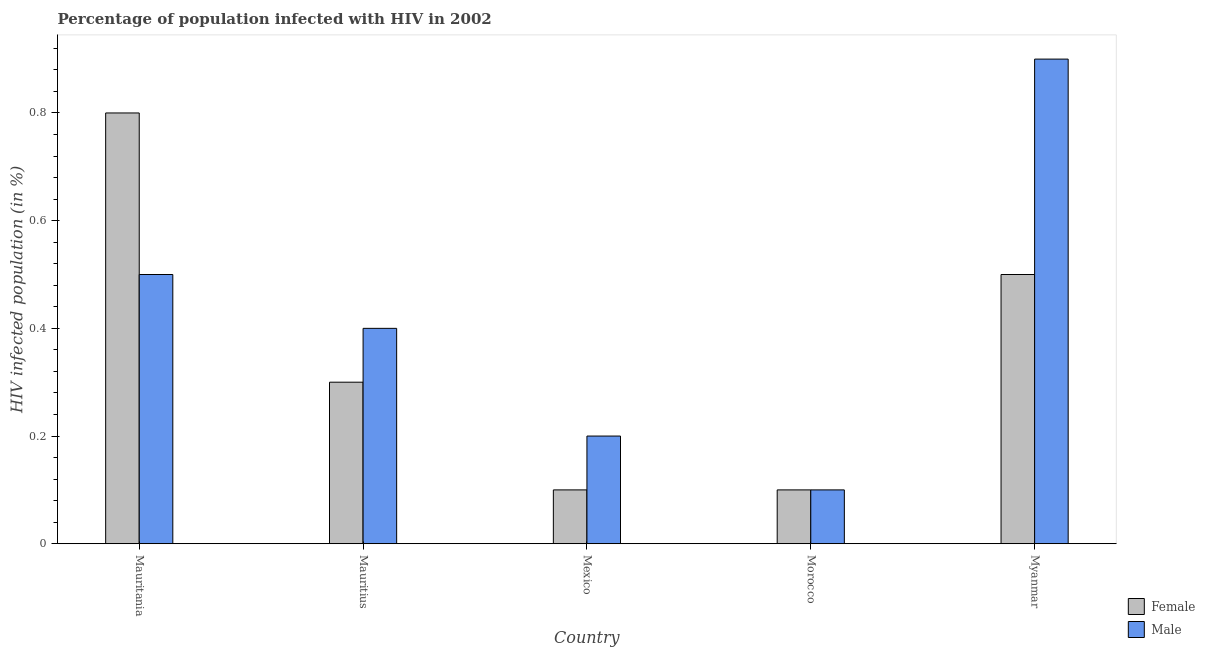How many different coloured bars are there?
Provide a succinct answer. 2. How many groups of bars are there?
Offer a terse response. 5. Are the number of bars on each tick of the X-axis equal?
Keep it short and to the point. Yes. How many bars are there on the 3rd tick from the left?
Ensure brevity in your answer.  2. What is the label of the 5th group of bars from the left?
Offer a terse response. Myanmar. What is the percentage of males who are infected with hiv in Mauritius?
Offer a terse response. 0.4. Across all countries, what is the maximum percentage of males who are infected with hiv?
Keep it short and to the point. 0.9. In which country was the percentage of females who are infected with hiv maximum?
Offer a terse response. Mauritania. In which country was the percentage of females who are infected with hiv minimum?
Your answer should be very brief. Mexico. What is the total percentage of males who are infected with hiv in the graph?
Your answer should be compact. 2.1. What is the average percentage of males who are infected with hiv per country?
Keep it short and to the point. 0.42. What is the difference between the percentage of females who are infected with hiv and percentage of males who are infected with hiv in Mauritania?
Make the answer very short. 0.3. In how many countries, is the percentage of males who are infected with hiv greater than 0.6400000000000001 %?
Provide a succinct answer. 1. What is the ratio of the percentage of males who are infected with hiv in Mauritania to that in Myanmar?
Keep it short and to the point. 0.56. What is the difference between the highest and the second highest percentage of males who are infected with hiv?
Provide a succinct answer. 0.4. What is the difference between the highest and the lowest percentage of females who are infected with hiv?
Ensure brevity in your answer.  0.7. Is the sum of the percentage of males who are infected with hiv in Mauritania and Mexico greater than the maximum percentage of females who are infected with hiv across all countries?
Offer a terse response. No. What does the 1st bar from the right in Mauritius represents?
Your answer should be very brief. Male. How many bars are there?
Keep it short and to the point. 10. Are all the bars in the graph horizontal?
Keep it short and to the point. No. What is the difference between two consecutive major ticks on the Y-axis?
Provide a short and direct response. 0.2. Does the graph contain grids?
Your answer should be compact. No. How are the legend labels stacked?
Make the answer very short. Vertical. What is the title of the graph?
Your response must be concise. Percentage of population infected with HIV in 2002. Does "Private consumption" appear as one of the legend labels in the graph?
Your answer should be very brief. No. What is the label or title of the X-axis?
Offer a very short reply. Country. What is the label or title of the Y-axis?
Your answer should be very brief. HIV infected population (in %). What is the HIV infected population (in %) of Female in Mauritania?
Make the answer very short. 0.8. What is the HIV infected population (in %) of Male in Mauritania?
Make the answer very short. 0.5. What is the HIV infected population (in %) of Female in Mauritius?
Offer a terse response. 0.3. What is the HIV infected population (in %) of Male in Mexico?
Provide a succinct answer. 0.2. What is the HIV infected population (in %) in Female in Morocco?
Provide a succinct answer. 0.1. What is the HIV infected population (in %) in Male in Myanmar?
Provide a short and direct response. 0.9. Across all countries, what is the maximum HIV infected population (in %) in Female?
Provide a short and direct response. 0.8. Across all countries, what is the maximum HIV infected population (in %) of Male?
Ensure brevity in your answer.  0.9. Across all countries, what is the minimum HIV infected population (in %) of Female?
Ensure brevity in your answer.  0.1. What is the total HIV infected population (in %) of Female in the graph?
Offer a very short reply. 1.8. What is the difference between the HIV infected population (in %) of Female in Mauritania and that in Mauritius?
Your answer should be very brief. 0.5. What is the difference between the HIV infected population (in %) of Male in Mauritania and that in Mauritius?
Give a very brief answer. 0.1. What is the difference between the HIV infected population (in %) of Male in Mauritania and that in Mexico?
Provide a short and direct response. 0.3. What is the difference between the HIV infected population (in %) in Female in Mauritania and that in Myanmar?
Provide a succinct answer. 0.3. What is the difference between the HIV infected population (in %) of Male in Mauritania and that in Myanmar?
Your response must be concise. -0.4. What is the difference between the HIV infected population (in %) of Female in Mauritius and that in Mexico?
Keep it short and to the point. 0.2. What is the difference between the HIV infected population (in %) in Male in Mauritius and that in Mexico?
Ensure brevity in your answer.  0.2. What is the difference between the HIV infected population (in %) of Female in Mauritius and that in Morocco?
Make the answer very short. 0.2. What is the difference between the HIV infected population (in %) of Male in Mauritius and that in Myanmar?
Offer a terse response. -0.5. What is the difference between the HIV infected population (in %) in Female in Mexico and that in Morocco?
Provide a short and direct response. 0. What is the difference between the HIV infected population (in %) in Male in Mexico and that in Morocco?
Your answer should be compact. 0.1. What is the difference between the HIV infected population (in %) in Female in Mexico and that in Myanmar?
Your answer should be compact. -0.4. What is the difference between the HIV infected population (in %) in Male in Mexico and that in Myanmar?
Your answer should be compact. -0.7. What is the difference between the HIV infected population (in %) of Male in Morocco and that in Myanmar?
Provide a short and direct response. -0.8. What is the difference between the HIV infected population (in %) in Female in Mauritania and the HIV infected population (in %) in Male in Mauritius?
Ensure brevity in your answer.  0.4. What is the difference between the HIV infected population (in %) of Female in Mauritania and the HIV infected population (in %) of Male in Mexico?
Your answer should be very brief. 0.6. What is the difference between the HIV infected population (in %) of Female in Mauritania and the HIV infected population (in %) of Male in Myanmar?
Offer a very short reply. -0.1. What is the difference between the HIV infected population (in %) in Female in Mauritius and the HIV infected population (in %) in Male in Mexico?
Provide a succinct answer. 0.1. What is the difference between the HIV infected population (in %) in Female in Mauritius and the HIV infected population (in %) in Male in Morocco?
Your answer should be very brief. 0.2. What is the difference between the HIV infected population (in %) of Female in Mauritius and the HIV infected population (in %) of Male in Myanmar?
Offer a terse response. -0.6. What is the difference between the HIV infected population (in %) of Female in Mexico and the HIV infected population (in %) of Male in Morocco?
Offer a very short reply. 0. What is the difference between the HIV infected population (in %) in Female in Mexico and the HIV infected population (in %) in Male in Myanmar?
Provide a short and direct response. -0.8. What is the difference between the HIV infected population (in %) of Female in Morocco and the HIV infected population (in %) of Male in Myanmar?
Your response must be concise. -0.8. What is the average HIV infected population (in %) of Female per country?
Your answer should be compact. 0.36. What is the average HIV infected population (in %) of Male per country?
Offer a very short reply. 0.42. What is the difference between the HIV infected population (in %) of Female and HIV infected population (in %) of Male in Mauritius?
Give a very brief answer. -0.1. What is the difference between the HIV infected population (in %) of Female and HIV infected population (in %) of Male in Morocco?
Offer a very short reply. 0. What is the ratio of the HIV infected population (in %) of Female in Mauritania to that in Mauritius?
Give a very brief answer. 2.67. What is the ratio of the HIV infected population (in %) in Female in Mauritania to that in Mexico?
Your response must be concise. 8. What is the ratio of the HIV infected population (in %) in Male in Mauritania to that in Mexico?
Your answer should be compact. 2.5. What is the ratio of the HIV infected population (in %) in Female in Mauritania to that in Morocco?
Keep it short and to the point. 8. What is the ratio of the HIV infected population (in %) in Female in Mauritania to that in Myanmar?
Keep it short and to the point. 1.6. What is the ratio of the HIV infected population (in %) in Male in Mauritania to that in Myanmar?
Provide a short and direct response. 0.56. What is the ratio of the HIV infected population (in %) of Female in Mauritius to that in Morocco?
Provide a short and direct response. 3. What is the ratio of the HIV infected population (in %) in Male in Mauritius to that in Myanmar?
Make the answer very short. 0.44. What is the ratio of the HIV infected population (in %) of Male in Mexico to that in Morocco?
Your answer should be very brief. 2. What is the ratio of the HIV infected population (in %) in Male in Mexico to that in Myanmar?
Provide a succinct answer. 0.22. What is the ratio of the HIV infected population (in %) of Male in Morocco to that in Myanmar?
Your response must be concise. 0.11. What is the difference between the highest and the second highest HIV infected population (in %) of Female?
Provide a short and direct response. 0.3. What is the difference between the highest and the lowest HIV infected population (in %) in Male?
Offer a very short reply. 0.8. 